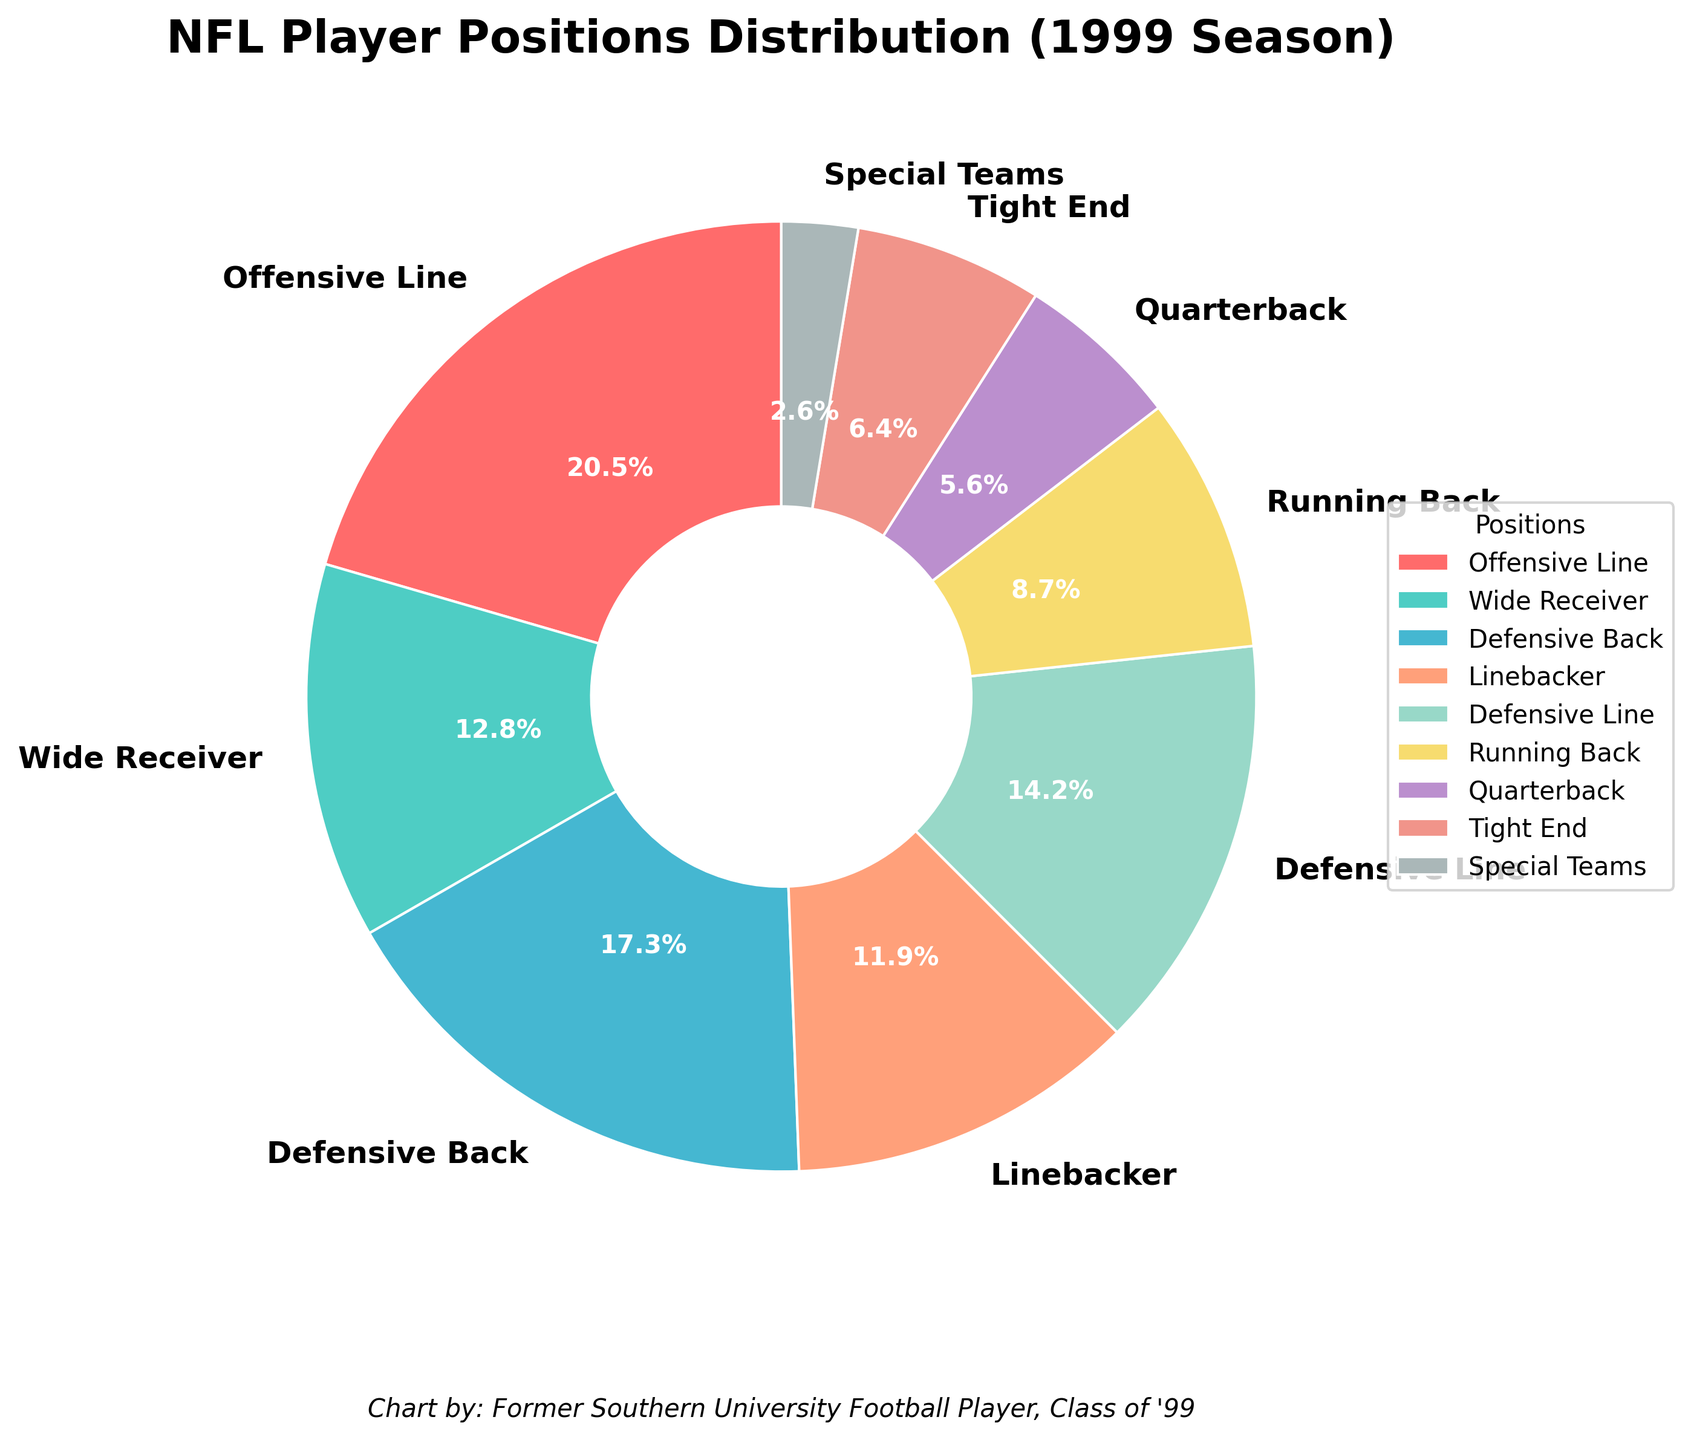Which position has the highest percentage of players in the NFL for the 1999 season? From the pie chart, the Offensive Line occupies the largest segment, indicating it has the highest percentage.
Answer: Offensive Line What is the combined percentage of Defensive Line and Linebacker players? The percentage for Defensive Line players is 14.2% and for Linebacker players is 11.9%. Summing these gives 14.2 + 11.9 = 26.1%.
Answer: 26.1% Is the percentage of Quarterbacks higher than that of Running Backs? The pie chart shows Quarterbacks at 5.6% and Running Backs at 8.7%. Comparing these, Quarterbacks have a lower percentage than Running Backs.
Answer: No Which positions are shown in shades of red? Visual inspection of the pie chart shows Offensive Line and Tight End segments in shades of red.
Answer: Offensive Line, Tight End Between Wide Receiver and Defensive Back, which position has a greater percentage and by how much? The percentage for Wide Receiver is 12.8%, and for Defensive Back, it is 17.3%. The difference is 17.3 - 12.8 = 4.5%.
Answer: Defensive Back, 4.5% What is the total percentage of Offensive-related positions (Offensive Line, Wide Receiver, Running Back, Quarterback, Tight End)? Adding the percentages for Offensive Line (20.5%), Wide Receiver (12.8%), Running Back (8.7%), Quarterback (5.6%), and Tight End (6.4%) gives 20.5 + 12.8 + 8.7 + 5.6 + 6.4 = 54%.
Answer: 54% Which position has the smallest percentage of players, and what is that percentage? The smallest segment in the pie chart corresponds to Special Teams with 2.6%.
Answer: Special Teams, 2.6% How does the sum of the percentages of Defensive Back and Defensive Line compare to the sum of Wide Receiver and Running Back? Defensive Back (17.3%) + Defensive Line (14.2%) = 31.5%. Wide Receiver (12.8%) + Running Back (8.7%) = 21.5%. Comparing these, 31.5% is greater than 21.5%.
Answer: 31.5% greater than 21.5% What percentage of players are neither Defensive Back nor Wide Receiver? Adding percentages of Defensive Back (17.3%) and Wide Receiver (12.8%) gives 17.3 + 12.8 = 30.1%. Subtracting from 100% gives 100 - 30.1 = 69.9%.
Answer: 69.9% 